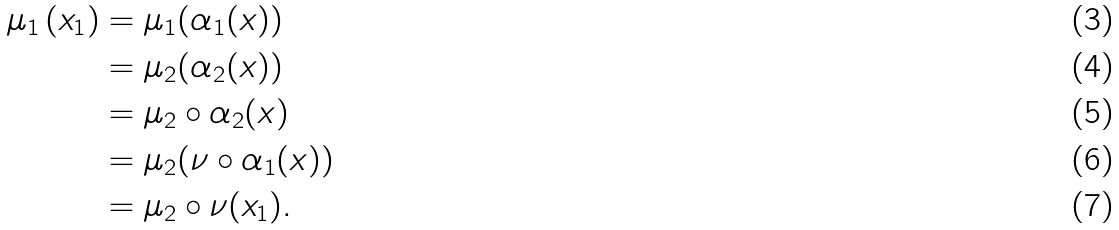Convert formula to latex. <formula><loc_0><loc_0><loc_500><loc_500>\mu _ { 1 } \left ( x _ { 1 } \right ) & = \mu _ { 1 } ( \alpha _ { 1 } ( x ) ) \\ & = \mu _ { 2 } ( \alpha _ { 2 } ( x ) ) \\ & = \mu _ { 2 } \circ \alpha _ { 2 } ( x ) \\ & = \mu _ { 2 } ( \nu \circ \alpha _ { 1 } ( x ) ) \\ & = \mu _ { 2 } \circ \nu ( x _ { 1 } ) .</formula> 